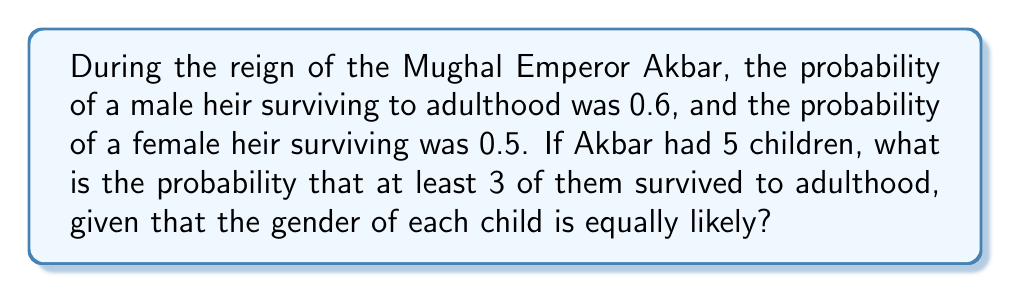Provide a solution to this math problem. Let's approach this step-by-step:

1) First, we need to calculate the overall probability of a child surviving, regardless of gender:
   $P(\text{survival}) = P(\text{male}) \cdot P(\text{male survival}) + P(\text{female}) \cdot P(\text{female survival})$
   $= 0.5 \cdot 0.6 + 0.5 \cdot 0.5 = 0.3 + 0.25 = 0.55$

2) Now, we can treat this as a binomial probability problem. We want the probability of at least 3 successes (survivals) out of 5 trials, where each trial has a probability of 0.55.

3) The probability of exactly $k$ successes in $n$ trials is given by the binomial probability formula:

   $P(X = k) = \binom{n}{k} p^k (1-p)^{n-k}$

   where $n$ is the number of trials, $k$ is the number of successes, $p$ is the probability of success on each trial.

4) We need to sum the probabilities for 3, 4, and 5 successes:

   $P(X \geq 3) = P(X = 3) + P(X = 4) + P(X = 5)$

5) Let's calculate each term:

   $P(X = 3) = \binom{5}{3} 0.55^3 (1-0.55)^{5-3} = 10 \cdot 0.55^3 \cdot 0.45^2 = 0.2936$

   $P(X = 4) = \binom{5}{4} 0.55^4 (1-0.55)^{5-4} = 5 \cdot 0.55^4 \cdot 0.45^1 = 0.1bit$

   $P(X = 5) = \binom{5}{5} 0.55^5 (1-0.55)^{5-5} = 1 \cdot 0.55^5 \cdot 0.45^0 = 0.0503$

6) Sum these probabilities:

   $P(X \geq 3) = 0.2936 + 0.1801 + 0.0503 = 0.5240$

Therefore, the probability that at least 3 out of Akbar's 5 children survived to adulthood is approximately 0.5240 or 52.40%.
Answer: 0.5240 